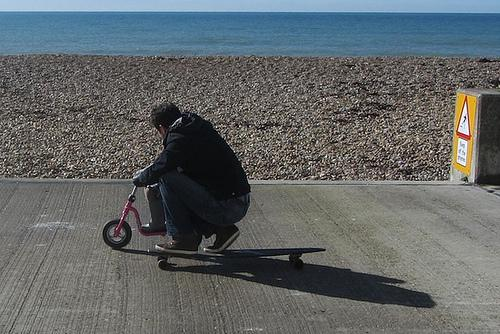Question: what is the weather like?
Choices:
A. Cloudy.
B. Overcast.
C. Rainy.
D. Sunny.
Answer with the letter. Answer: D Question: why is the man kneeling?
Choices:
A. To rest.
B. Holding on to small bike.
C. To pick up the child.
D. To pick up his wallet.
Answer with the letter. Answer: B Question: where is the man?
Choices:
A. On the boat.
B. In the car.
C. On boardwalk.
D. On the bridge.
Answer with the letter. Answer: C 